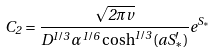Convert formula to latex. <formula><loc_0><loc_0><loc_500><loc_500>C _ { 2 } = \frac { \sqrt { 2 \pi v } } { D ^ { 1 / 3 } \alpha ^ { 1 / 6 } \cosh ^ { 1 / 3 } ( a S _ { * } ^ { \prime } ) } e ^ { S _ { * } }</formula> 